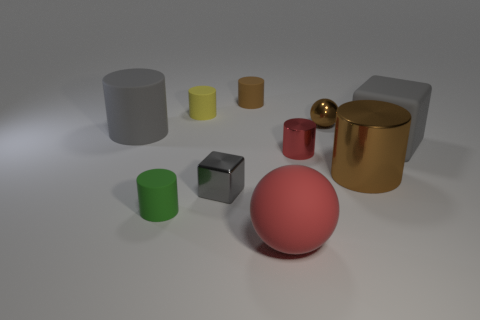The rubber cylinder that is the same color as the tiny shiny ball is what size?
Your answer should be compact. Small. Is the big brown cylinder made of the same material as the big red thing?
Provide a succinct answer. No. How many things are spheres that are to the left of the brown ball or matte things that are to the left of the brown metal cylinder?
Keep it short and to the point. 5. Is there a brown cylinder of the same size as the yellow cylinder?
Offer a very short reply. Yes. What is the color of the other thing that is the same shape as the big red object?
Offer a very short reply. Brown. Are there any tiny shiny things that are behind the brown metal object behind the large metal thing?
Offer a very short reply. No. There is a big gray matte thing on the right side of the green cylinder; is its shape the same as the gray metal object?
Provide a short and direct response. Yes. What shape is the green object?
Offer a very short reply. Cylinder. What number of big green objects have the same material as the small yellow object?
Your answer should be very brief. 0. There is a large matte sphere; does it have the same color as the metallic cylinder that is to the left of the big brown metallic cylinder?
Offer a terse response. Yes. 